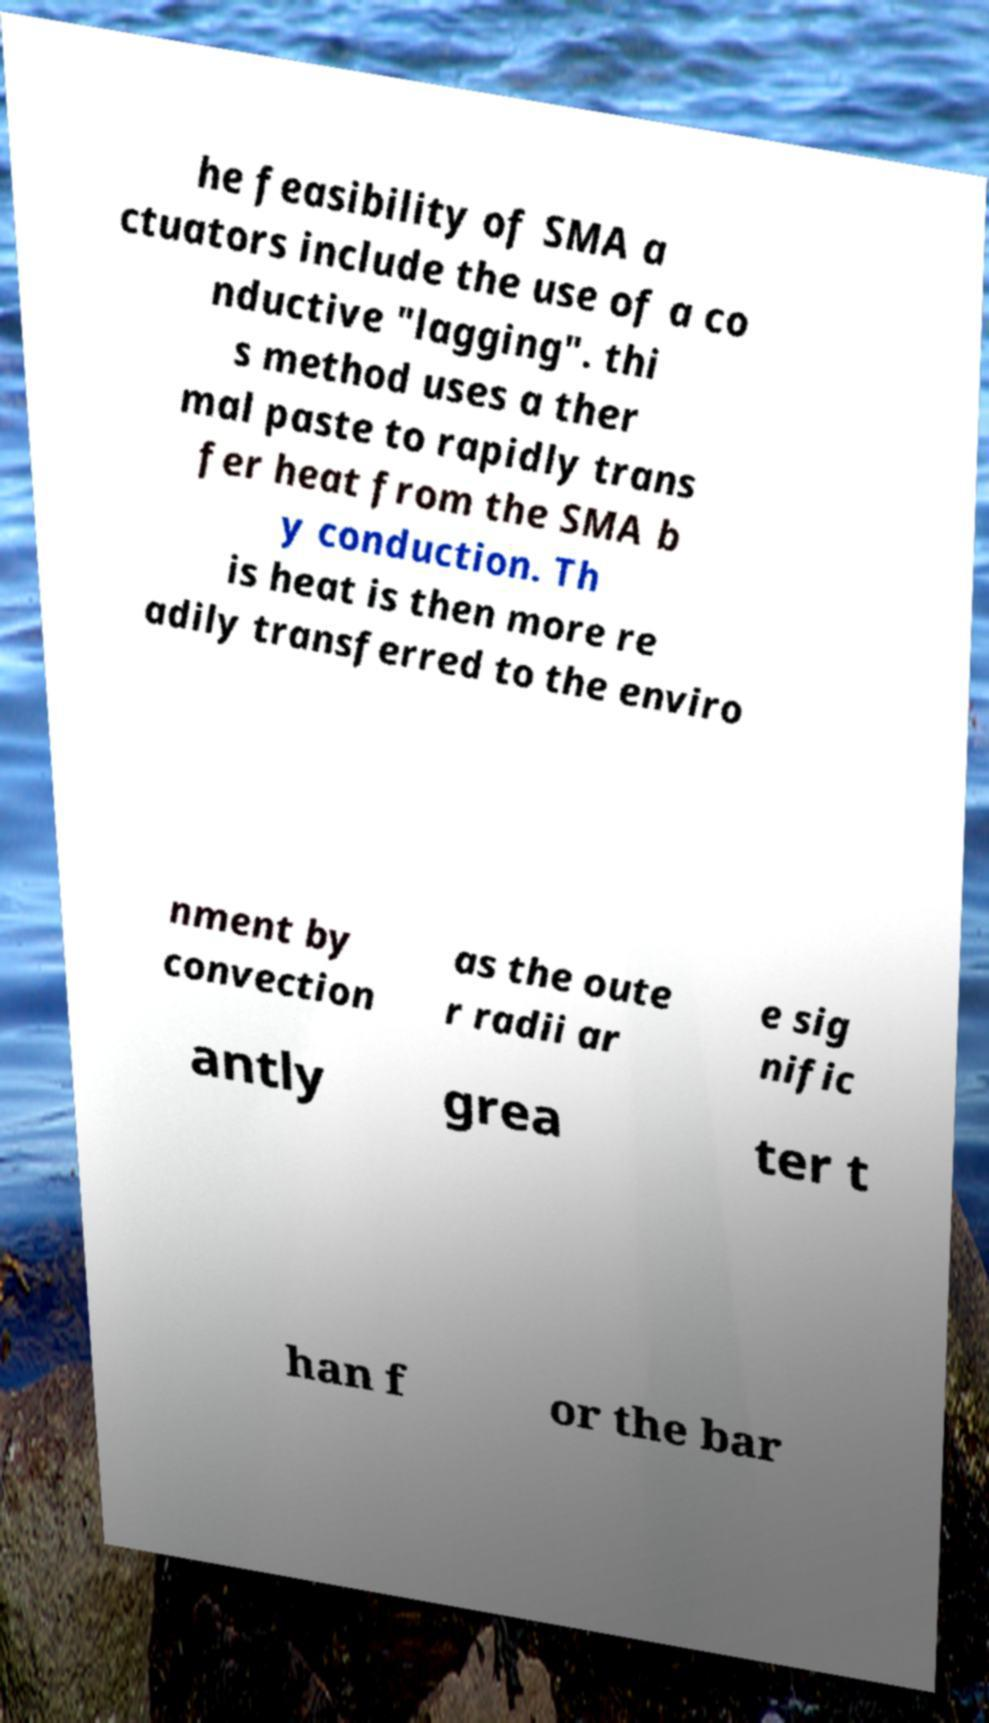What messages or text are displayed in this image? I need them in a readable, typed format. he feasibility of SMA a ctuators include the use of a co nductive "lagging". thi s method uses a ther mal paste to rapidly trans fer heat from the SMA b y conduction. Th is heat is then more re adily transferred to the enviro nment by convection as the oute r radii ar e sig nific antly grea ter t han f or the bar 